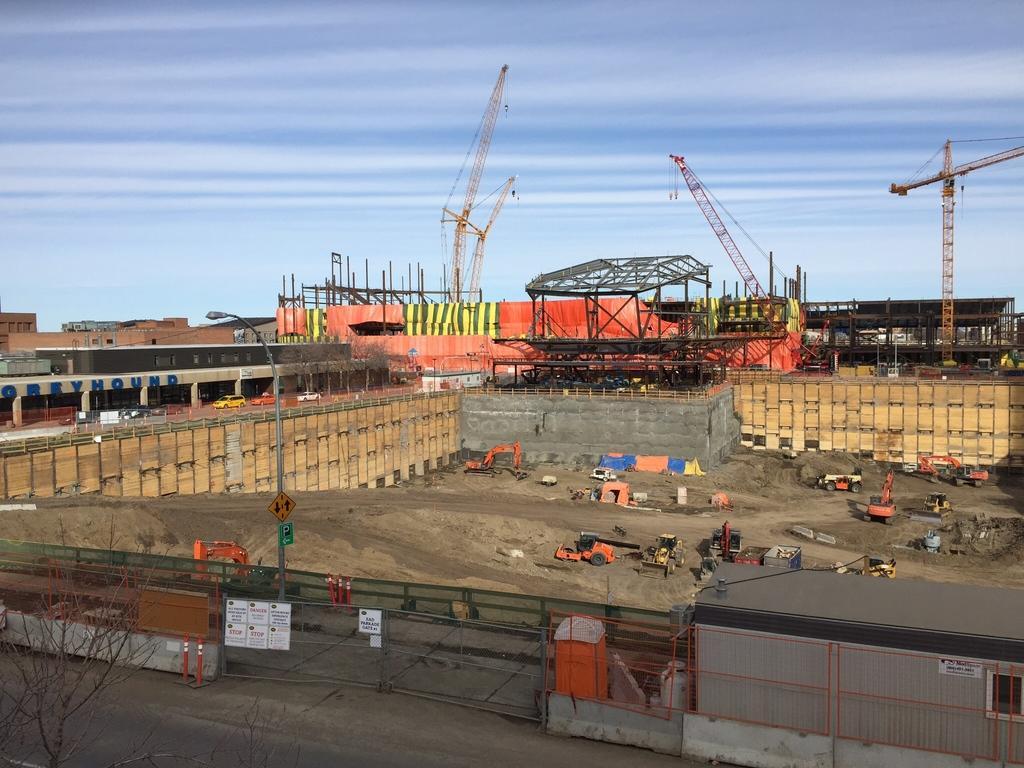How would you summarize this image in a sentence or two? In this image, we can see a construction site, there are some cranes, we can see the fence, at the top we can see the sky. 